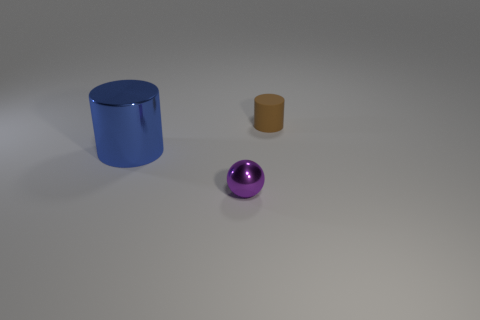What number of blocks are small rubber things or big blue metal things?
Offer a terse response. 0. How many metallic things are the same color as the shiny cylinder?
Your answer should be compact. 0. What size is the thing that is both to the right of the big blue object and to the left of the rubber cylinder?
Provide a succinct answer. Small. Is the number of balls to the right of the purple shiny object less than the number of brown rubber cylinders?
Your answer should be very brief. Yes. Are the large blue cylinder and the tiny purple object made of the same material?
Provide a succinct answer. Yes. How many things are tiny cyan cubes or brown cylinders?
Ensure brevity in your answer.  1. How many large gray things have the same material as the tiny purple sphere?
Offer a very short reply. 0. What is the size of the other object that is the same shape as the brown object?
Provide a short and direct response. Large. There is a big cylinder; are there any matte cylinders behind it?
Your response must be concise. Yes. What is the large blue cylinder made of?
Provide a short and direct response. Metal. 